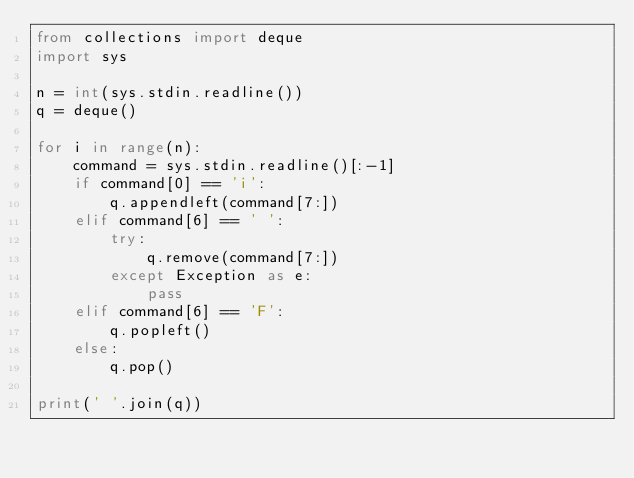Convert code to text. <code><loc_0><loc_0><loc_500><loc_500><_Python_>from collections import deque
import sys
 
n = int(sys.stdin.readline())
q = deque()
 
for i in range(n):
    command = sys.stdin.readline()[:-1]
    if command[0] == 'i':
        q.appendleft(command[7:])
    elif command[6] == ' ':
        try:
            q.remove(command[7:])
        except Exception as e:
            pass
    elif command[6] == 'F':
        q.popleft()
    else:
        q.pop()
 
print(' '.join(q))</code> 